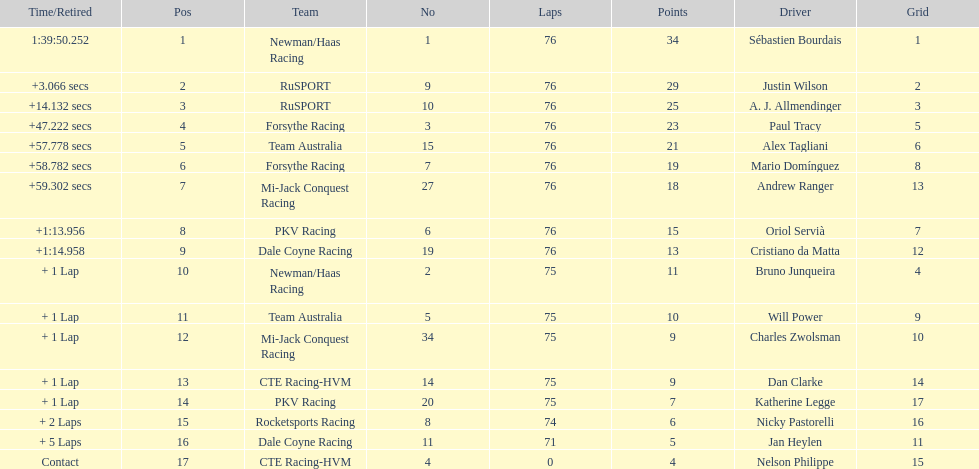How many positions are held by canada? 3. 